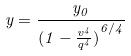Convert formula to latex. <formula><loc_0><loc_0><loc_500><loc_500>y = \frac { y _ { 0 } } { ( { 1 - \frac { v ^ { 4 } } { q ^ { 4 } } ) } ^ { 6 / 4 } }</formula> 